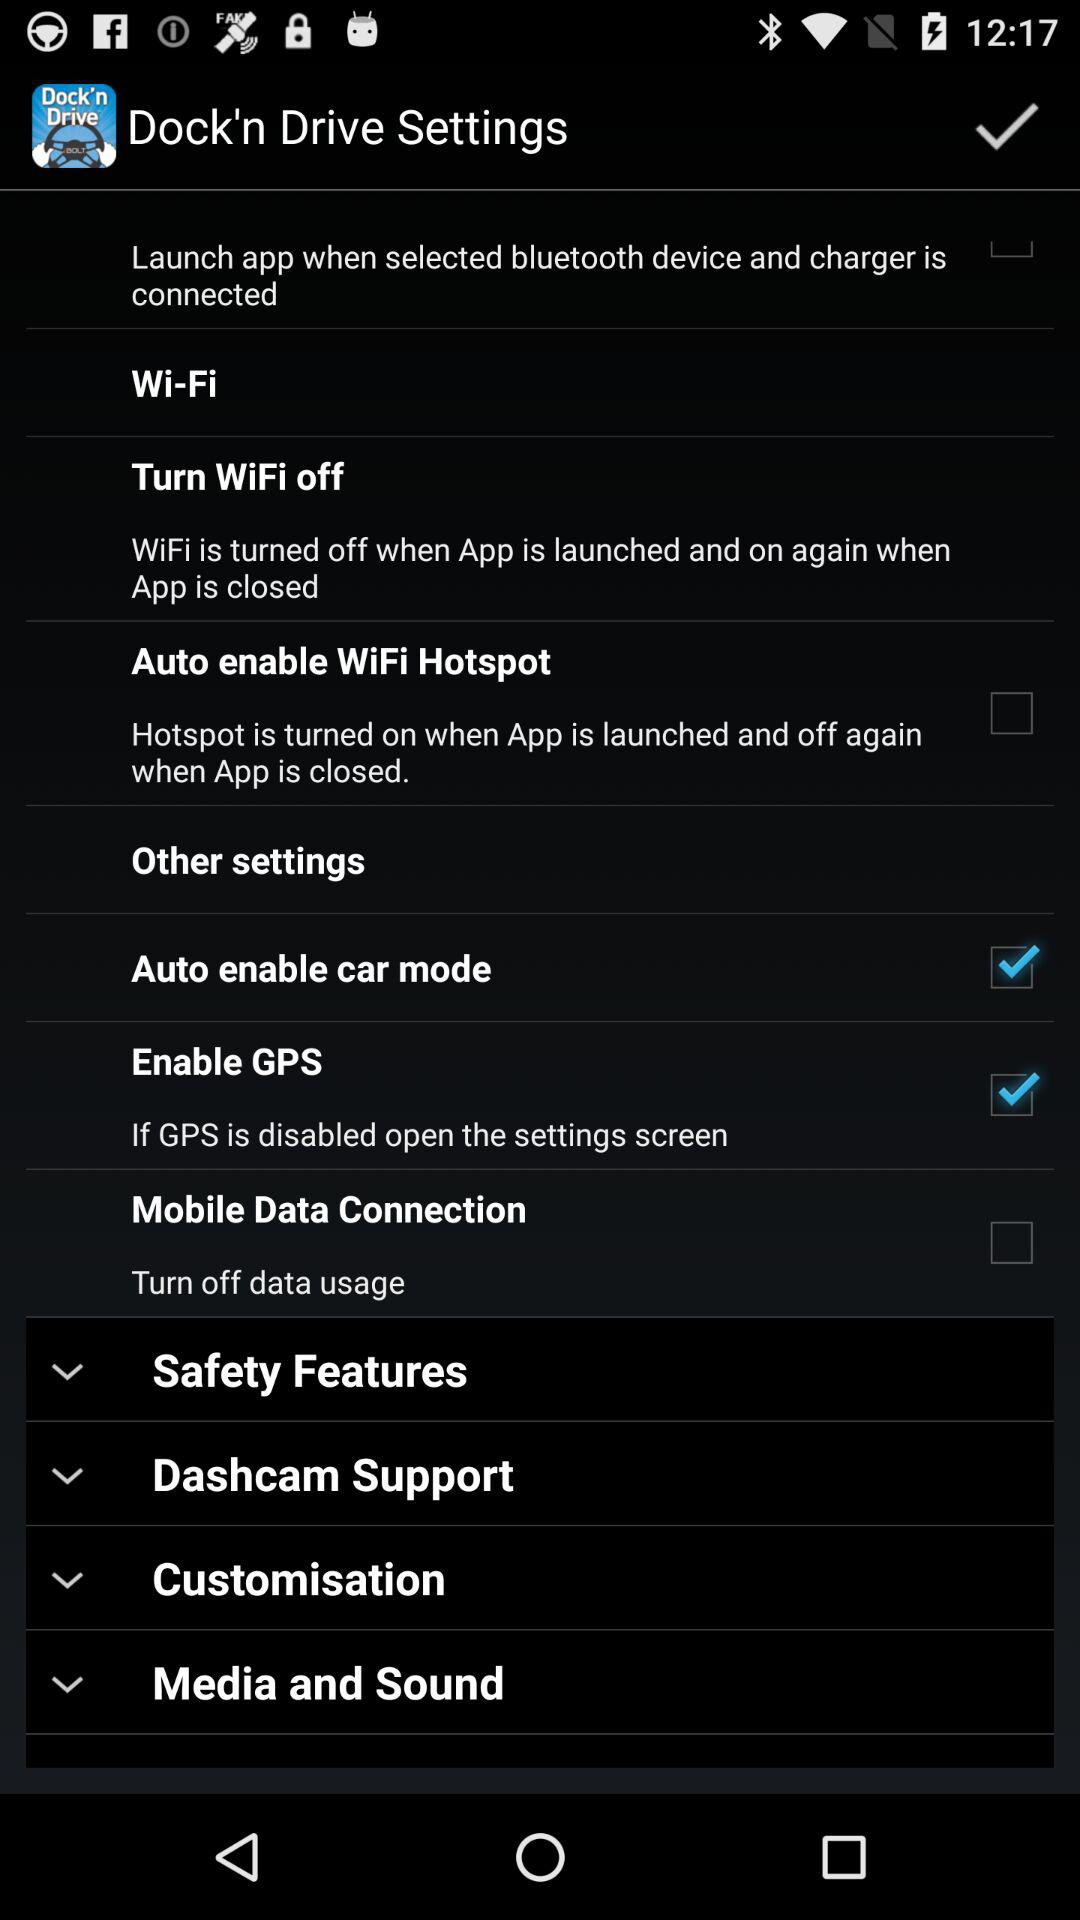What is the status of "Auto enable WiFi Hotspot"? The status is "off". 